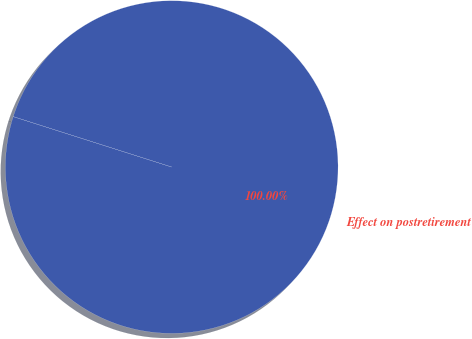Convert chart to OTSL. <chart><loc_0><loc_0><loc_500><loc_500><pie_chart><fcel>Effect on postretirement<nl><fcel>100.0%<nl></chart> 